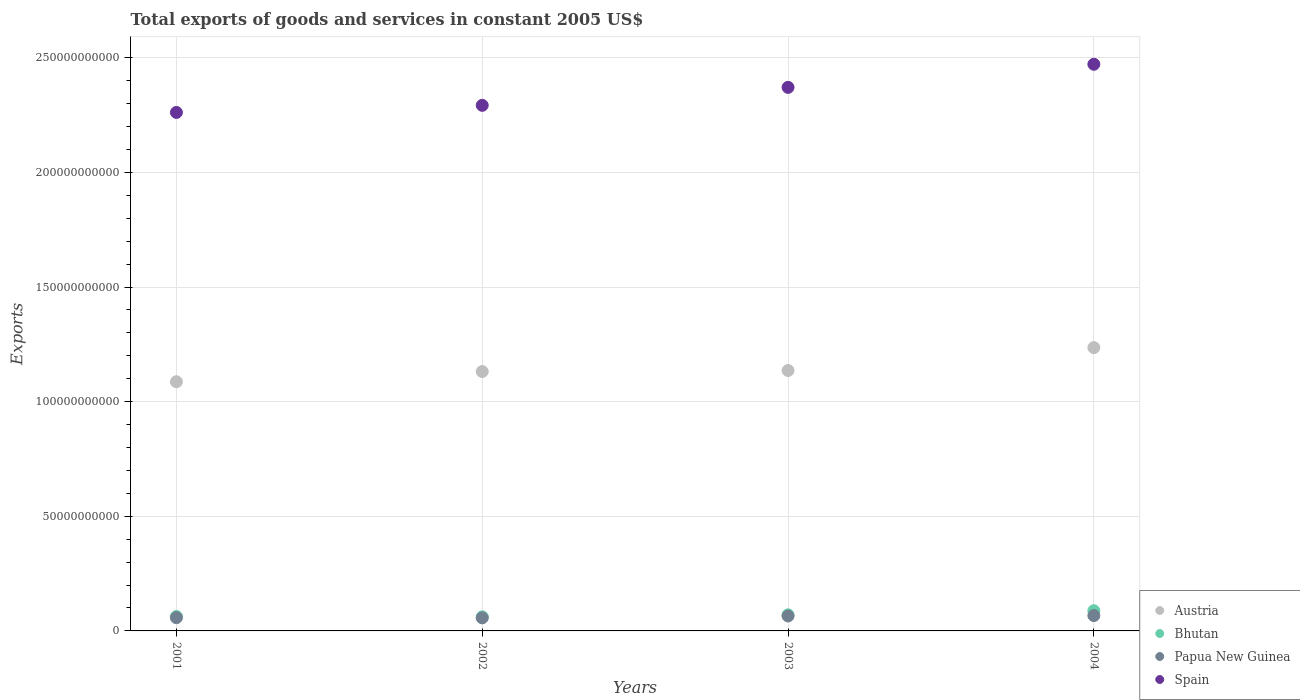What is the total exports of goods and services in Bhutan in 2001?
Provide a short and direct response. 6.29e+09. Across all years, what is the maximum total exports of goods and services in Spain?
Your answer should be very brief. 2.47e+11. Across all years, what is the minimum total exports of goods and services in Spain?
Keep it short and to the point. 2.26e+11. In which year was the total exports of goods and services in Spain maximum?
Ensure brevity in your answer.  2004. In which year was the total exports of goods and services in Bhutan minimum?
Provide a succinct answer. 2002. What is the total total exports of goods and services in Austria in the graph?
Provide a succinct answer. 4.59e+11. What is the difference between the total exports of goods and services in Spain in 2003 and that in 2004?
Your answer should be very brief. -1.01e+1. What is the difference between the total exports of goods and services in Papua New Guinea in 2004 and the total exports of goods and services in Spain in 2002?
Keep it short and to the point. -2.23e+11. What is the average total exports of goods and services in Bhutan per year?
Your response must be concise. 7.06e+09. In the year 2003, what is the difference between the total exports of goods and services in Papua New Guinea and total exports of goods and services in Bhutan?
Offer a terse response. -4.99e+08. What is the ratio of the total exports of goods and services in Spain in 2003 to that in 2004?
Offer a very short reply. 0.96. What is the difference between the highest and the second highest total exports of goods and services in Bhutan?
Give a very brief answer. 1.79e+09. What is the difference between the highest and the lowest total exports of goods and services in Austria?
Make the answer very short. 1.49e+1. Is it the case that in every year, the sum of the total exports of goods and services in Spain and total exports of goods and services in Bhutan  is greater than the sum of total exports of goods and services in Papua New Guinea and total exports of goods and services in Austria?
Provide a short and direct response. Yes. Is the total exports of goods and services in Papua New Guinea strictly greater than the total exports of goods and services in Bhutan over the years?
Your answer should be very brief. No. How many dotlines are there?
Provide a short and direct response. 4. How many years are there in the graph?
Your answer should be compact. 4. What is the difference between two consecutive major ticks on the Y-axis?
Offer a very short reply. 5.00e+1. Are the values on the major ticks of Y-axis written in scientific E-notation?
Make the answer very short. No. Does the graph contain any zero values?
Provide a short and direct response. No. How are the legend labels stacked?
Make the answer very short. Vertical. What is the title of the graph?
Keep it short and to the point. Total exports of goods and services in constant 2005 US$. What is the label or title of the Y-axis?
Make the answer very short. Exports. What is the Exports of Austria in 2001?
Provide a short and direct response. 1.09e+11. What is the Exports in Bhutan in 2001?
Give a very brief answer. 6.29e+09. What is the Exports in Papua New Guinea in 2001?
Your answer should be compact. 5.78e+09. What is the Exports in Spain in 2001?
Give a very brief answer. 2.26e+11. What is the Exports of Austria in 2002?
Provide a short and direct response. 1.13e+11. What is the Exports of Bhutan in 2002?
Provide a succinct answer. 6.14e+09. What is the Exports of Papua New Guinea in 2002?
Ensure brevity in your answer.  5.70e+09. What is the Exports of Spain in 2002?
Your answer should be very brief. 2.29e+11. What is the Exports of Austria in 2003?
Keep it short and to the point. 1.14e+11. What is the Exports of Bhutan in 2003?
Keep it short and to the point. 7.02e+09. What is the Exports of Papua New Guinea in 2003?
Make the answer very short. 6.52e+09. What is the Exports in Spain in 2003?
Offer a very short reply. 2.37e+11. What is the Exports of Austria in 2004?
Provide a succinct answer. 1.24e+11. What is the Exports of Bhutan in 2004?
Your answer should be compact. 8.81e+09. What is the Exports in Papua New Guinea in 2004?
Your response must be concise. 6.69e+09. What is the Exports of Spain in 2004?
Ensure brevity in your answer.  2.47e+11. Across all years, what is the maximum Exports of Austria?
Provide a short and direct response. 1.24e+11. Across all years, what is the maximum Exports in Bhutan?
Your response must be concise. 8.81e+09. Across all years, what is the maximum Exports of Papua New Guinea?
Ensure brevity in your answer.  6.69e+09. Across all years, what is the maximum Exports in Spain?
Offer a very short reply. 2.47e+11. Across all years, what is the minimum Exports of Austria?
Provide a succinct answer. 1.09e+11. Across all years, what is the minimum Exports of Bhutan?
Make the answer very short. 6.14e+09. Across all years, what is the minimum Exports in Papua New Guinea?
Offer a terse response. 5.70e+09. Across all years, what is the minimum Exports of Spain?
Your answer should be compact. 2.26e+11. What is the total Exports of Austria in the graph?
Ensure brevity in your answer.  4.59e+11. What is the total Exports in Bhutan in the graph?
Your answer should be very brief. 2.83e+1. What is the total Exports in Papua New Guinea in the graph?
Your response must be concise. 2.47e+1. What is the total Exports of Spain in the graph?
Offer a very short reply. 9.40e+11. What is the difference between the Exports of Austria in 2001 and that in 2002?
Provide a succinct answer. -4.45e+09. What is the difference between the Exports of Bhutan in 2001 and that in 2002?
Ensure brevity in your answer.  1.52e+08. What is the difference between the Exports of Papua New Guinea in 2001 and that in 2002?
Your answer should be compact. 7.26e+07. What is the difference between the Exports in Spain in 2001 and that in 2002?
Ensure brevity in your answer.  -3.09e+09. What is the difference between the Exports in Austria in 2001 and that in 2003?
Your answer should be compact. -4.91e+09. What is the difference between the Exports of Bhutan in 2001 and that in 2003?
Provide a succinct answer. -7.24e+08. What is the difference between the Exports of Papua New Guinea in 2001 and that in 2003?
Provide a succinct answer. -7.41e+08. What is the difference between the Exports of Spain in 2001 and that in 2003?
Your answer should be very brief. -1.09e+1. What is the difference between the Exports of Austria in 2001 and that in 2004?
Ensure brevity in your answer.  -1.49e+1. What is the difference between the Exports of Bhutan in 2001 and that in 2004?
Your response must be concise. -2.52e+09. What is the difference between the Exports of Papua New Guinea in 2001 and that in 2004?
Offer a very short reply. -9.18e+08. What is the difference between the Exports in Spain in 2001 and that in 2004?
Provide a succinct answer. -2.10e+1. What is the difference between the Exports of Austria in 2002 and that in 2003?
Offer a very short reply. -4.55e+08. What is the difference between the Exports in Bhutan in 2002 and that in 2003?
Provide a short and direct response. -8.76e+08. What is the difference between the Exports of Papua New Guinea in 2002 and that in 2003?
Provide a succinct answer. -8.13e+08. What is the difference between the Exports of Spain in 2002 and that in 2003?
Provide a succinct answer. -7.84e+09. What is the difference between the Exports in Austria in 2002 and that in 2004?
Your response must be concise. -1.04e+1. What is the difference between the Exports in Bhutan in 2002 and that in 2004?
Ensure brevity in your answer.  -2.67e+09. What is the difference between the Exports of Papua New Guinea in 2002 and that in 2004?
Offer a terse response. -9.90e+08. What is the difference between the Exports in Spain in 2002 and that in 2004?
Your answer should be compact. -1.79e+1. What is the difference between the Exports of Austria in 2003 and that in 2004?
Offer a terse response. -9.98e+09. What is the difference between the Exports in Bhutan in 2003 and that in 2004?
Your answer should be compact. -1.79e+09. What is the difference between the Exports in Papua New Guinea in 2003 and that in 2004?
Provide a succinct answer. -1.77e+08. What is the difference between the Exports of Spain in 2003 and that in 2004?
Provide a short and direct response. -1.01e+1. What is the difference between the Exports in Austria in 2001 and the Exports in Bhutan in 2002?
Provide a succinct answer. 1.03e+11. What is the difference between the Exports in Austria in 2001 and the Exports in Papua New Guinea in 2002?
Keep it short and to the point. 1.03e+11. What is the difference between the Exports in Austria in 2001 and the Exports in Spain in 2002?
Your answer should be very brief. -1.21e+11. What is the difference between the Exports of Bhutan in 2001 and the Exports of Papua New Guinea in 2002?
Offer a terse response. 5.88e+08. What is the difference between the Exports in Bhutan in 2001 and the Exports in Spain in 2002?
Keep it short and to the point. -2.23e+11. What is the difference between the Exports of Papua New Guinea in 2001 and the Exports of Spain in 2002?
Make the answer very short. -2.23e+11. What is the difference between the Exports in Austria in 2001 and the Exports in Bhutan in 2003?
Make the answer very short. 1.02e+11. What is the difference between the Exports of Austria in 2001 and the Exports of Papua New Guinea in 2003?
Your response must be concise. 1.02e+11. What is the difference between the Exports of Austria in 2001 and the Exports of Spain in 2003?
Offer a terse response. -1.28e+11. What is the difference between the Exports of Bhutan in 2001 and the Exports of Papua New Guinea in 2003?
Your answer should be compact. -2.25e+08. What is the difference between the Exports in Bhutan in 2001 and the Exports in Spain in 2003?
Your answer should be compact. -2.31e+11. What is the difference between the Exports of Papua New Guinea in 2001 and the Exports of Spain in 2003?
Offer a terse response. -2.31e+11. What is the difference between the Exports of Austria in 2001 and the Exports of Bhutan in 2004?
Make the answer very short. 9.99e+1. What is the difference between the Exports of Austria in 2001 and the Exports of Papua New Guinea in 2004?
Your response must be concise. 1.02e+11. What is the difference between the Exports in Austria in 2001 and the Exports in Spain in 2004?
Your response must be concise. -1.38e+11. What is the difference between the Exports in Bhutan in 2001 and the Exports in Papua New Guinea in 2004?
Keep it short and to the point. -4.02e+08. What is the difference between the Exports in Bhutan in 2001 and the Exports in Spain in 2004?
Give a very brief answer. -2.41e+11. What is the difference between the Exports in Papua New Guinea in 2001 and the Exports in Spain in 2004?
Make the answer very short. -2.41e+11. What is the difference between the Exports of Austria in 2002 and the Exports of Bhutan in 2003?
Your response must be concise. 1.06e+11. What is the difference between the Exports in Austria in 2002 and the Exports in Papua New Guinea in 2003?
Provide a succinct answer. 1.07e+11. What is the difference between the Exports of Austria in 2002 and the Exports of Spain in 2003?
Provide a short and direct response. -1.24e+11. What is the difference between the Exports of Bhutan in 2002 and the Exports of Papua New Guinea in 2003?
Ensure brevity in your answer.  -3.77e+08. What is the difference between the Exports of Bhutan in 2002 and the Exports of Spain in 2003?
Make the answer very short. -2.31e+11. What is the difference between the Exports in Papua New Guinea in 2002 and the Exports in Spain in 2003?
Provide a short and direct response. -2.31e+11. What is the difference between the Exports in Austria in 2002 and the Exports in Bhutan in 2004?
Ensure brevity in your answer.  1.04e+11. What is the difference between the Exports of Austria in 2002 and the Exports of Papua New Guinea in 2004?
Offer a very short reply. 1.06e+11. What is the difference between the Exports of Austria in 2002 and the Exports of Spain in 2004?
Your response must be concise. -1.34e+11. What is the difference between the Exports of Bhutan in 2002 and the Exports of Papua New Guinea in 2004?
Give a very brief answer. -5.54e+08. What is the difference between the Exports of Bhutan in 2002 and the Exports of Spain in 2004?
Ensure brevity in your answer.  -2.41e+11. What is the difference between the Exports in Papua New Guinea in 2002 and the Exports in Spain in 2004?
Offer a very short reply. -2.41e+11. What is the difference between the Exports in Austria in 2003 and the Exports in Bhutan in 2004?
Provide a short and direct response. 1.05e+11. What is the difference between the Exports of Austria in 2003 and the Exports of Papua New Guinea in 2004?
Your answer should be very brief. 1.07e+11. What is the difference between the Exports in Austria in 2003 and the Exports in Spain in 2004?
Offer a terse response. -1.34e+11. What is the difference between the Exports in Bhutan in 2003 and the Exports in Papua New Guinea in 2004?
Provide a short and direct response. 3.22e+08. What is the difference between the Exports in Bhutan in 2003 and the Exports in Spain in 2004?
Provide a short and direct response. -2.40e+11. What is the difference between the Exports in Papua New Guinea in 2003 and the Exports in Spain in 2004?
Offer a terse response. -2.41e+11. What is the average Exports in Austria per year?
Provide a short and direct response. 1.15e+11. What is the average Exports of Bhutan per year?
Your answer should be very brief. 7.06e+09. What is the average Exports of Papua New Guinea per year?
Provide a short and direct response. 6.17e+09. What is the average Exports of Spain per year?
Your answer should be very brief. 2.35e+11. In the year 2001, what is the difference between the Exports of Austria and Exports of Bhutan?
Your answer should be compact. 1.02e+11. In the year 2001, what is the difference between the Exports in Austria and Exports in Papua New Guinea?
Keep it short and to the point. 1.03e+11. In the year 2001, what is the difference between the Exports of Austria and Exports of Spain?
Your response must be concise. -1.17e+11. In the year 2001, what is the difference between the Exports of Bhutan and Exports of Papua New Guinea?
Ensure brevity in your answer.  5.16e+08. In the year 2001, what is the difference between the Exports of Bhutan and Exports of Spain?
Make the answer very short. -2.20e+11. In the year 2001, what is the difference between the Exports of Papua New Guinea and Exports of Spain?
Provide a short and direct response. -2.20e+11. In the year 2002, what is the difference between the Exports of Austria and Exports of Bhutan?
Offer a very short reply. 1.07e+11. In the year 2002, what is the difference between the Exports of Austria and Exports of Papua New Guinea?
Your answer should be compact. 1.07e+11. In the year 2002, what is the difference between the Exports of Austria and Exports of Spain?
Make the answer very short. -1.16e+11. In the year 2002, what is the difference between the Exports of Bhutan and Exports of Papua New Guinea?
Keep it short and to the point. 4.36e+08. In the year 2002, what is the difference between the Exports in Bhutan and Exports in Spain?
Ensure brevity in your answer.  -2.23e+11. In the year 2002, what is the difference between the Exports of Papua New Guinea and Exports of Spain?
Provide a short and direct response. -2.24e+11. In the year 2003, what is the difference between the Exports in Austria and Exports in Bhutan?
Your answer should be compact. 1.07e+11. In the year 2003, what is the difference between the Exports in Austria and Exports in Papua New Guinea?
Provide a succinct answer. 1.07e+11. In the year 2003, what is the difference between the Exports in Austria and Exports in Spain?
Your response must be concise. -1.23e+11. In the year 2003, what is the difference between the Exports of Bhutan and Exports of Papua New Guinea?
Your answer should be very brief. 4.99e+08. In the year 2003, what is the difference between the Exports of Bhutan and Exports of Spain?
Your answer should be compact. -2.30e+11. In the year 2003, what is the difference between the Exports in Papua New Guinea and Exports in Spain?
Provide a short and direct response. -2.31e+11. In the year 2004, what is the difference between the Exports of Austria and Exports of Bhutan?
Offer a terse response. 1.15e+11. In the year 2004, what is the difference between the Exports of Austria and Exports of Papua New Guinea?
Offer a terse response. 1.17e+11. In the year 2004, what is the difference between the Exports in Austria and Exports in Spain?
Make the answer very short. -1.24e+11. In the year 2004, what is the difference between the Exports of Bhutan and Exports of Papua New Guinea?
Your response must be concise. 2.11e+09. In the year 2004, what is the difference between the Exports of Bhutan and Exports of Spain?
Your answer should be very brief. -2.38e+11. In the year 2004, what is the difference between the Exports in Papua New Guinea and Exports in Spain?
Ensure brevity in your answer.  -2.40e+11. What is the ratio of the Exports of Austria in 2001 to that in 2002?
Provide a short and direct response. 0.96. What is the ratio of the Exports in Bhutan in 2001 to that in 2002?
Ensure brevity in your answer.  1.02. What is the ratio of the Exports of Papua New Guinea in 2001 to that in 2002?
Keep it short and to the point. 1.01. What is the ratio of the Exports in Spain in 2001 to that in 2002?
Your answer should be very brief. 0.99. What is the ratio of the Exports in Austria in 2001 to that in 2003?
Keep it short and to the point. 0.96. What is the ratio of the Exports in Bhutan in 2001 to that in 2003?
Offer a very short reply. 0.9. What is the ratio of the Exports of Papua New Guinea in 2001 to that in 2003?
Your answer should be compact. 0.89. What is the ratio of the Exports in Spain in 2001 to that in 2003?
Provide a short and direct response. 0.95. What is the ratio of the Exports of Austria in 2001 to that in 2004?
Provide a short and direct response. 0.88. What is the ratio of the Exports of Bhutan in 2001 to that in 2004?
Your answer should be very brief. 0.71. What is the ratio of the Exports of Papua New Guinea in 2001 to that in 2004?
Keep it short and to the point. 0.86. What is the ratio of the Exports in Spain in 2001 to that in 2004?
Ensure brevity in your answer.  0.92. What is the ratio of the Exports in Austria in 2002 to that in 2003?
Your answer should be very brief. 1. What is the ratio of the Exports of Bhutan in 2002 to that in 2003?
Provide a succinct answer. 0.88. What is the ratio of the Exports of Papua New Guinea in 2002 to that in 2003?
Provide a short and direct response. 0.88. What is the ratio of the Exports in Spain in 2002 to that in 2003?
Keep it short and to the point. 0.97. What is the ratio of the Exports in Austria in 2002 to that in 2004?
Make the answer very short. 0.92. What is the ratio of the Exports in Bhutan in 2002 to that in 2004?
Your answer should be very brief. 0.7. What is the ratio of the Exports of Papua New Guinea in 2002 to that in 2004?
Offer a very short reply. 0.85. What is the ratio of the Exports of Spain in 2002 to that in 2004?
Make the answer very short. 0.93. What is the ratio of the Exports in Austria in 2003 to that in 2004?
Ensure brevity in your answer.  0.92. What is the ratio of the Exports in Bhutan in 2003 to that in 2004?
Give a very brief answer. 0.8. What is the ratio of the Exports of Papua New Guinea in 2003 to that in 2004?
Make the answer very short. 0.97. What is the ratio of the Exports of Spain in 2003 to that in 2004?
Your response must be concise. 0.96. What is the difference between the highest and the second highest Exports of Austria?
Offer a terse response. 9.98e+09. What is the difference between the highest and the second highest Exports in Bhutan?
Provide a succinct answer. 1.79e+09. What is the difference between the highest and the second highest Exports in Papua New Guinea?
Make the answer very short. 1.77e+08. What is the difference between the highest and the second highest Exports in Spain?
Provide a succinct answer. 1.01e+1. What is the difference between the highest and the lowest Exports of Austria?
Your answer should be very brief. 1.49e+1. What is the difference between the highest and the lowest Exports of Bhutan?
Your answer should be very brief. 2.67e+09. What is the difference between the highest and the lowest Exports of Papua New Guinea?
Give a very brief answer. 9.90e+08. What is the difference between the highest and the lowest Exports of Spain?
Your answer should be compact. 2.10e+1. 